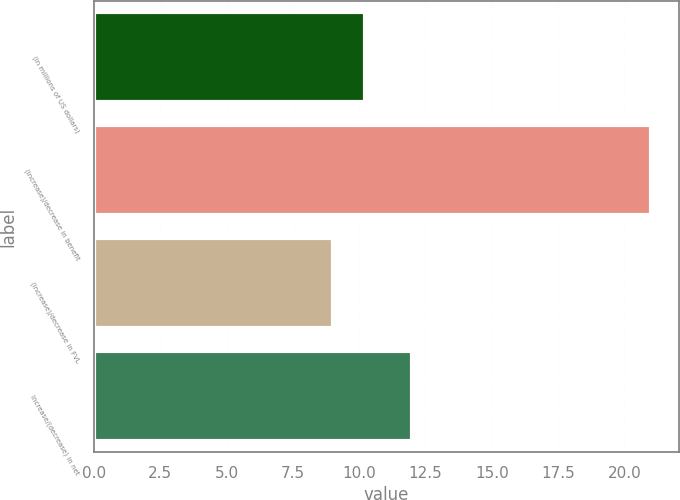<chart> <loc_0><loc_0><loc_500><loc_500><bar_chart><fcel>(in millions of US dollars)<fcel>(Increase)/decrease in benefit<fcel>(Increase)/decrease in FVL<fcel>Increase/(decrease) in net<nl><fcel>10.2<fcel>21<fcel>9<fcel>12<nl></chart> 